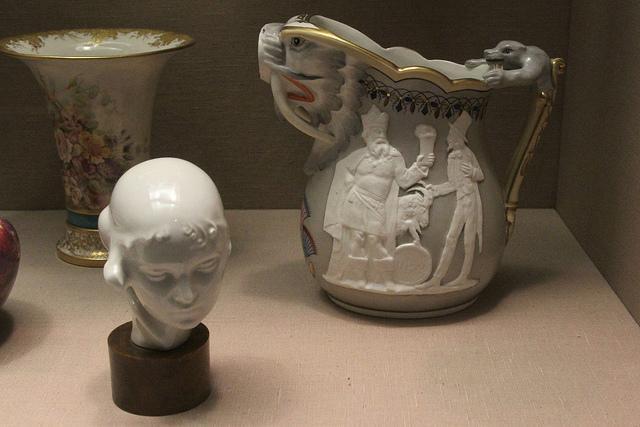How many items are pictured?
Give a very brief answer. 3. How many vase in the picture?
Give a very brief answer. 2. How many vases can be seen?
Give a very brief answer. 2. How many people are inside the kitchen?
Give a very brief answer. 0. 